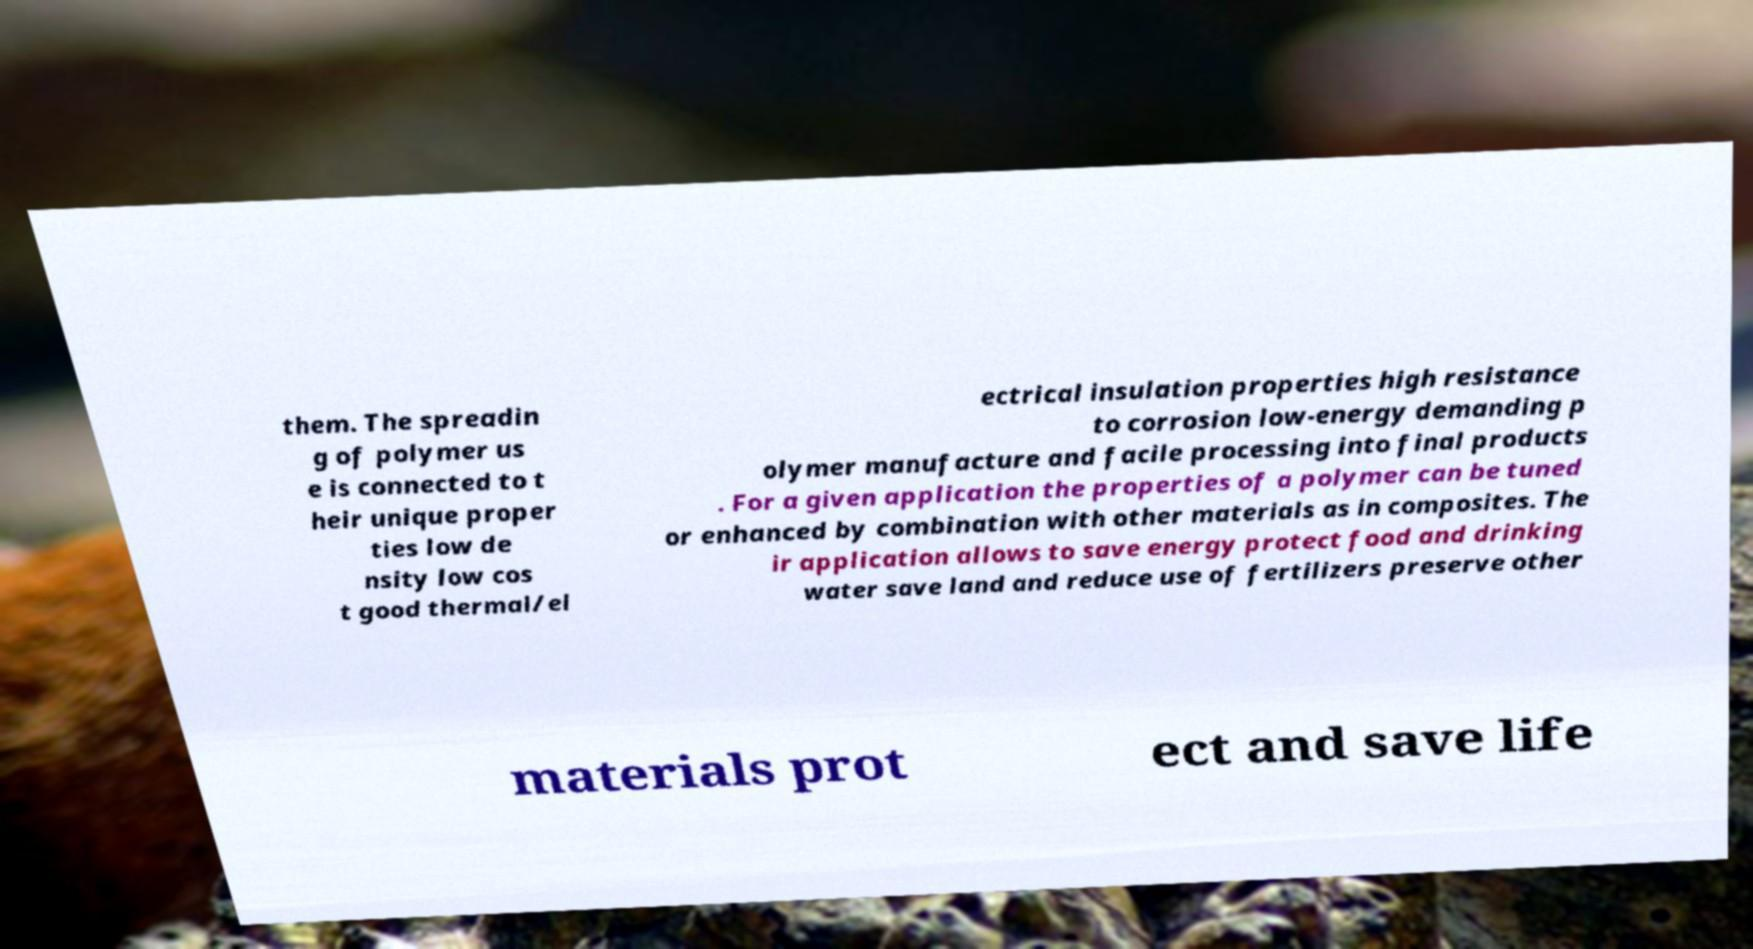Could you extract and type out the text from this image? them. The spreadin g of polymer us e is connected to t heir unique proper ties low de nsity low cos t good thermal/el ectrical insulation properties high resistance to corrosion low-energy demanding p olymer manufacture and facile processing into final products . For a given application the properties of a polymer can be tuned or enhanced by combination with other materials as in composites. The ir application allows to save energy protect food and drinking water save land and reduce use of fertilizers preserve other materials prot ect and save life 